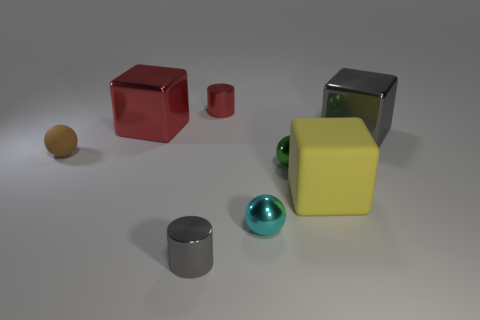Add 1 cyan metallic things. How many objects exist? 9 Subtract 0 purple cylinders. How many objects are left? 8 Subtract all cubes. How many objects are left? 5 Subtract 1 balls. How many balls are left? 2 Subtract all blue balls. Subtract all red cylinders. How many balls are left? 3 Subtract all gray cubes. How many red spheres are left? 0 Subtract all gray spheres. Subtract all red objects. How many objects are left? 6 Add 6 cyan shiny objects. How many cyan shiny objects are left? 7 Add 4 rubber spheres. How many rubber spheres exist? 5 Subtract all red blocks. How many blocks are left? 2 